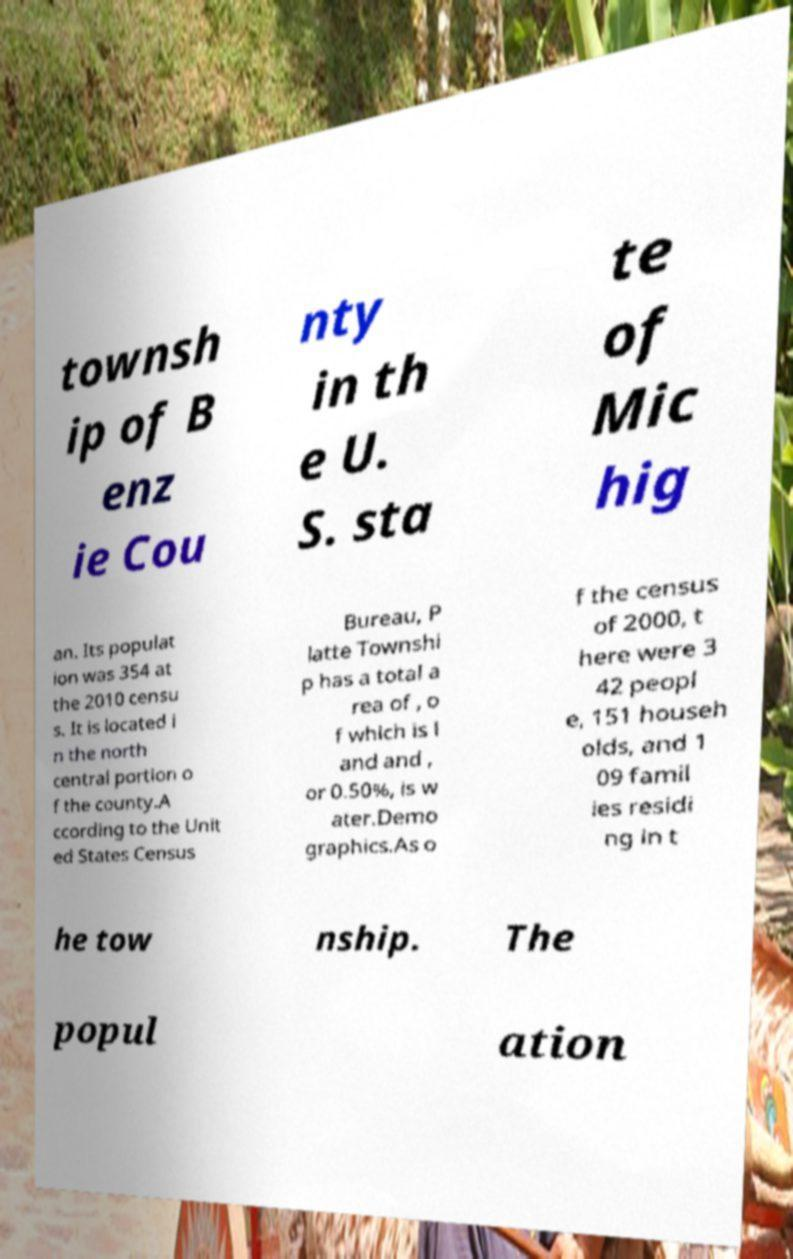Can you accurately transcribe the text from the provided image for me? townsh ip of B enz ie Cou nty in th e U. S. sta te of Mic hig an. Its populat ion was 354 at the 2010 censu s. It is located i n the north central portion o f the county.A ccording to the Unit ed States Census Bureau, P latte Townshi p has a total a rea of , o f which is l and and , or 0.50%, is w ater.Demo graphics.As o f the census of 2000, t here were 3 42 peopl e, 151 househ olds, and 1 09 famil ies residi ng in t he tow nship. The popul ation 